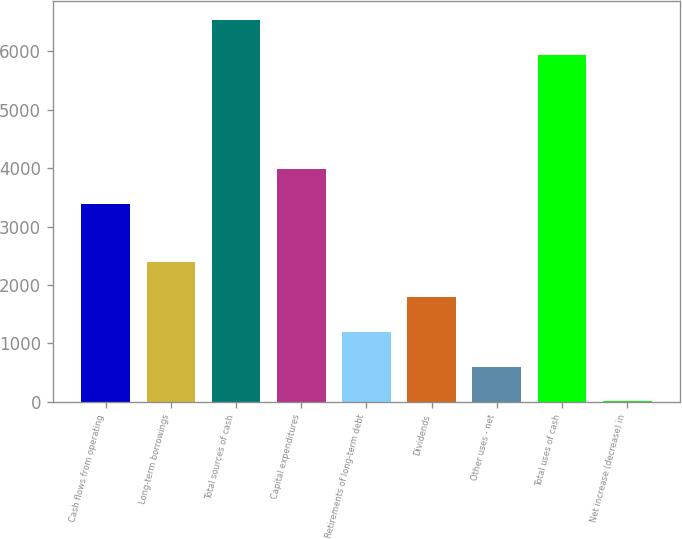Convert chart to OTSL. <chart><loc_0><loc_0><loc_500><loc_500><bar_chart><fcel>Cash flows from operating<fcel>Long-term borrowings<fcel>Total sources of cash<fcel>Capital expenditures<fcel>Retirements of long-term debt<fcel>Dividends<fcel>Other uses - net<fcel>Total uses of cash<fcel>Net increase (decrease) in<nl><fcel>3393<fcel>2385.4<fcel>6535.1<fcel>3987.1<fcel>1197.2<fcel>1791.3<fcel>603.1<fcel>5941<fcel>9<nl></chart> 